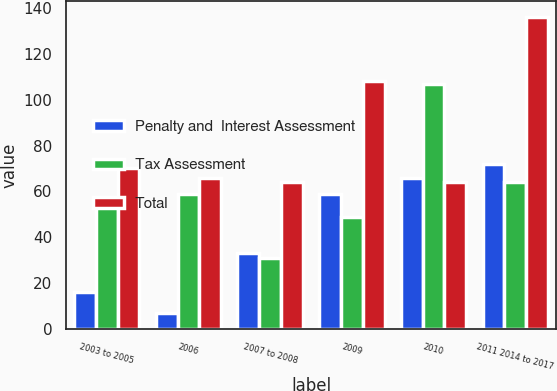Convert chart. <chart><loc_0><loc_0><loc_500><loc_500><stacked_bar_chart><ecel><fcel>2003 to 2005<fcel>2006<fcel>2007 to 2008<fcel>2009<fcel>2010<fcel>2011 2014 to 2017<nl><fcel>Penalty and  Interest Assessment<fcel>16<fcel>7<fcel>33<fcel>59<fcel>66<fcel>72<nl><fcel>Tax Assessment<fcel>54<fcel>59<fcel>31<fcel>49<fcel>107<fcel>64<nl><fcel>Total<fcel>70<fcel>66<fcel>64<fcel>108<fcel>64<fcel>136<nl></chart> 